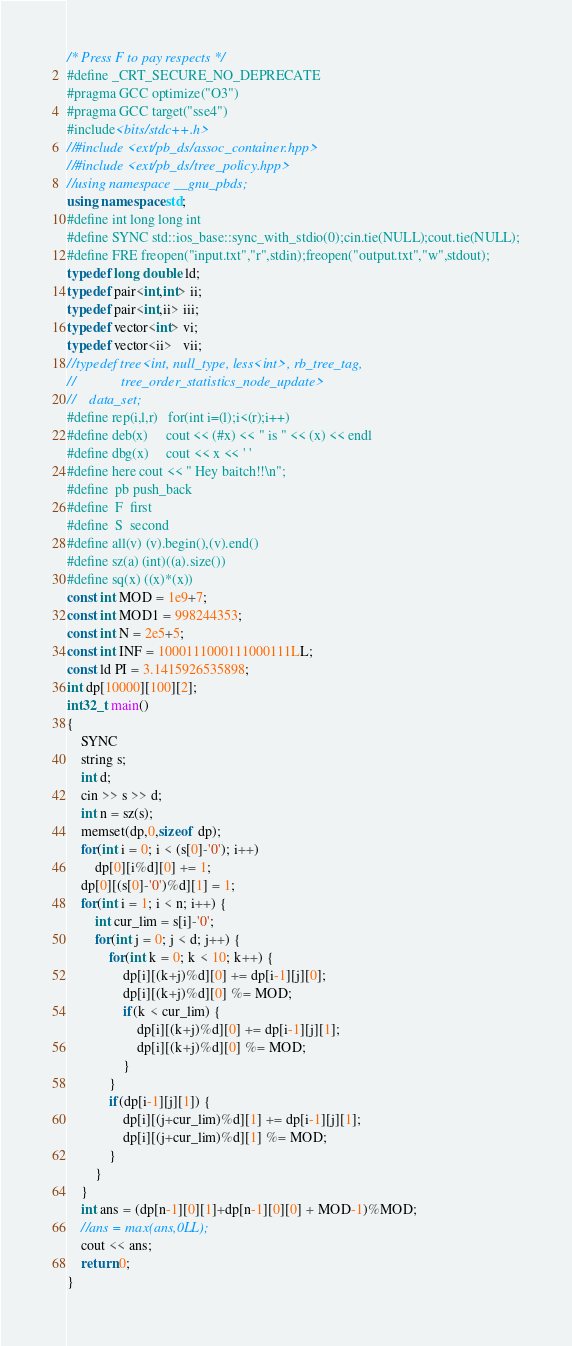<code> <loc_0><loc_0><loc_500><loc_500><_C++_>/* Press F to pay respects */
#define _CRT_SECURE_NO_DEPRECATE
#pragma GCC optimize("O3")
#pragma GCC target("sse4")
#include<bits/stdc++.h>
//#include <ext/pb_ds/assoc_container.hpp>
//#include <ext/pb_ds/tree_policy.hpp>
//using namespace __gnu_pbds; 
using namespace std;
#define int long long int
#define SYNC std::ios_base::sync_with_stdio(0);cin.tie(NULL);cout.tie(NULL);
#define FRE freopen("input.txt","r",stdin);freopen("output.txt","w",stdout);
typedef long double ld;
typedef pair<int,int> ii;
typedef pair<int,ii> iii;
typedef vector<int> vi;
typedef vector<ii>   vii;
//typedef tree<int, null_type, less<int>, rb_tree_tag, 
//             tree_order_statistics_node_update> 
//    data_set;
#define rep(i,l,r)   for(int i=(l);i<(r);i++)
#define deb(x)     cout << (#x) << " is " << (x) << endl
#define dbg(x)     cout << x << ' '
#define here cout << " Hey baitch!!\n";
#define  pb push_back
#define  F  first
#define  S  second
#define all(v) (v).begin(),(v).end()
#define sz(a) (int)((a).size())
#define sq(x) ((x)*(x))
const int MOD = 1e9+7;
const int MOD1 = 998244353;
const int N = 2e5+5;
const int INF = 1000111000111000111LL;
const ld PI = 3.1415926535898;
int dp[10000][100][2];
int32_t main()
{
	SYNC
	string s;
	int d;
	cin >> s >> d;
	int n = sz(s);
	memset(dp,0,sizeof dp);
	for(int i = 0; i < (s[0]-'0'); i++)
		dp[0][i%d][0] += 1;
	dp[0][(s[0]-'0')%d][1] = 1;
	for(int i = 1; i < n; i++) {
		int cur_lim = s[i]-'0';
		for(int j = 0; j < d; j++) {
			for(int k = 0; k < 10; k++) {
				dp[i][(k+j)%d][0] += dp[i-1][j][0];
				dp[i][(k+j)%d][0] %= MOD;
				if(k < cur_lim) {
					dp[i][(k+j)%d][0] += dp[i-1][j][1];
					dp[i][(k+j)%d][0] %= MOD;
				}
			}
			if(dp[i-1][j][1]) {
				dp[i][(j+cur_lim)%d][1] += dp[i-1][j][1];
				dp[i][(j+cur_lim)%d][1] %= MOD;
			}	
		}
	}
	int ans = (dp[n-1][0][1]+dp[n-1][0][0] + MOD-1)%MOD;
	//ans = max(ans,0LL);
	cout << ans;
    return 0;
}</code> 